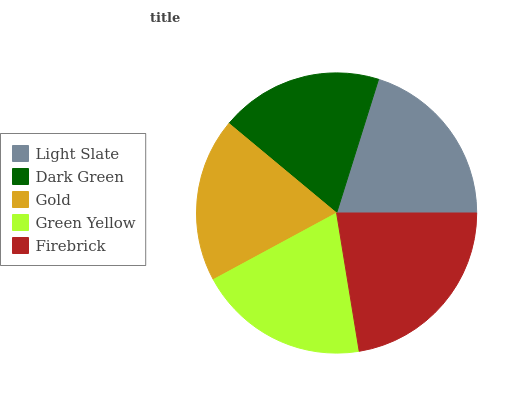Is Dark Green the minimum?
Answer yes or no. Yes. Is Firebrick the maximum?
Answer yes or no. Yes. Is Gold the minimum?
Answer yes or no. No. Is Gold the maximum?
Answer yes or no. No. Is Gold greater than Dark Green?
Answer yes or no. Yes. Is Dark Green less than Gold?
Answer yes or no. Yes. Is Dark Green greater than Gold?
Answer yes or no. No. Is Gold less than Dark Green?
Answer yes or no. No. Is Green Yellow the high median?
Answer yes or no. Yes. Is Green Yellow the low median?
Answer yes or no. Yes. Is Dark Green the high median?
Answer yes or no. No. Is Dark Green the low median?
Answer yes or no. No. 